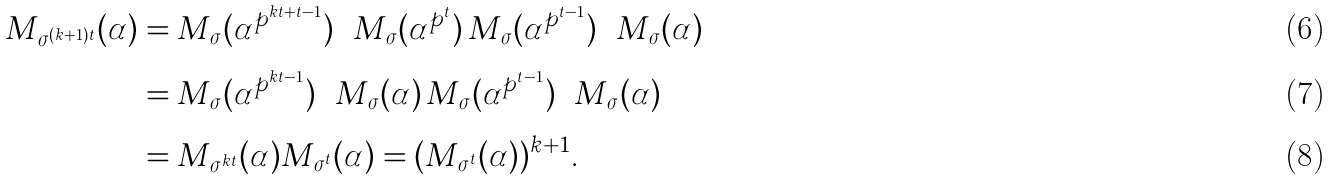Convert formula to latex. <formula><loc_0><loc_0><loc_500><loc_500>M _ { \sigma ^ { ( k + 1 ) t } } ( \alpha ) & = \underbrace { M _ { \sigma } ( \alpha ^ { p ^ { k t + t - 1 } } ) \cdots M _ { \sigma } ( \alpha ^ { p ^ { t } } ) } M _ { \sigma } ( \alpha ^ { p ^ { t - 1 } } ) \cdots M _ { \sigma } ( \alpha ) \\ & = \underbrace { M _ { \sigma } ( \alpha ^ { p ^ { k t - 1 } } ) \cdots M _ { \sigma } ( \alpha ) } \underbrace { M _ { \sigma } ( \alpha ^ { p ^ { t - 1 } } ) \cdots M _ { \sigma } ( \alpha ) } \\ & = M _ { \sigma ^ { k t } } ( \alpha ) M _ { \sigma ^ { t } } ( \alpha ) = ( M _ { \sigma ^ { t } } ( \alpha ) ) ^ { k + 1 } .</formula> 